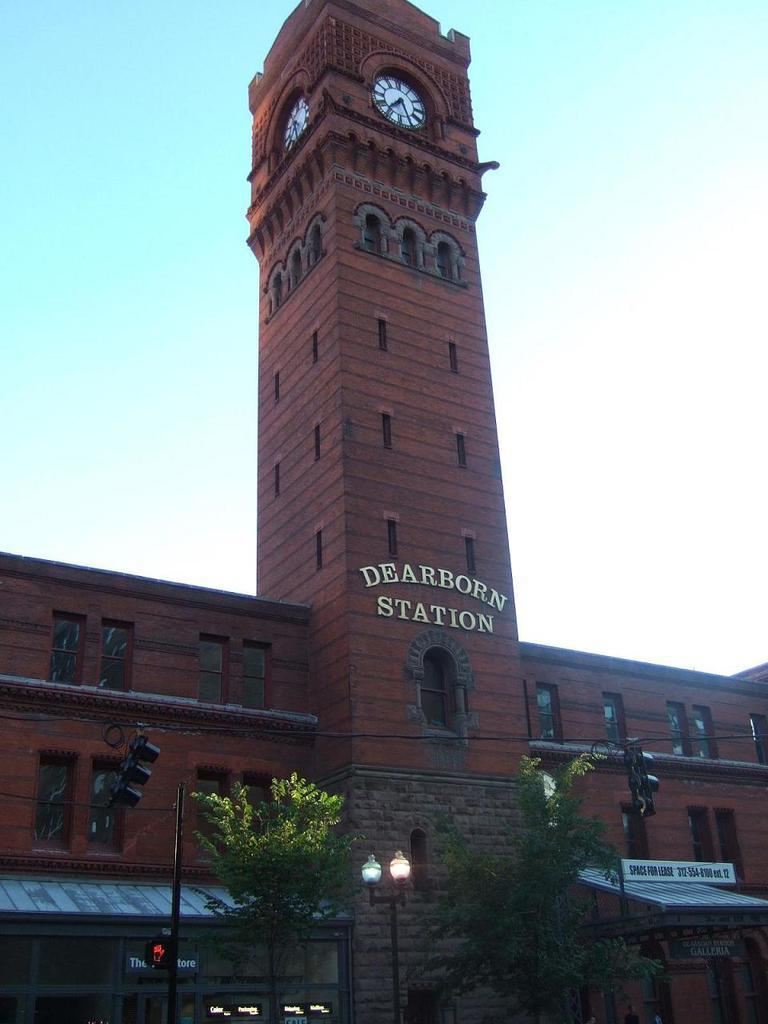What type of structure is visible in the image? There is a building in the image. What else can be seen in the image besides the building? There is text, clocks on the wall, trees, poles, and the sky visible in the image. Where are the trees and poles located in the image? The trees and poles are in the foreground of the image. What is visible at the top of the image? The sky is visible at the top of the image. How many women are playing the guitar in the image? There are no women or guitars present in the image. What type of jam is being spread on the toast in the image? There is no toast or jam present in the image. 